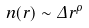Convert formula to latex. <formula><loc_0><loc_0><loc_500><loc_500>n ( r ) \sim \Delta r ^ { \rho }</formula> 